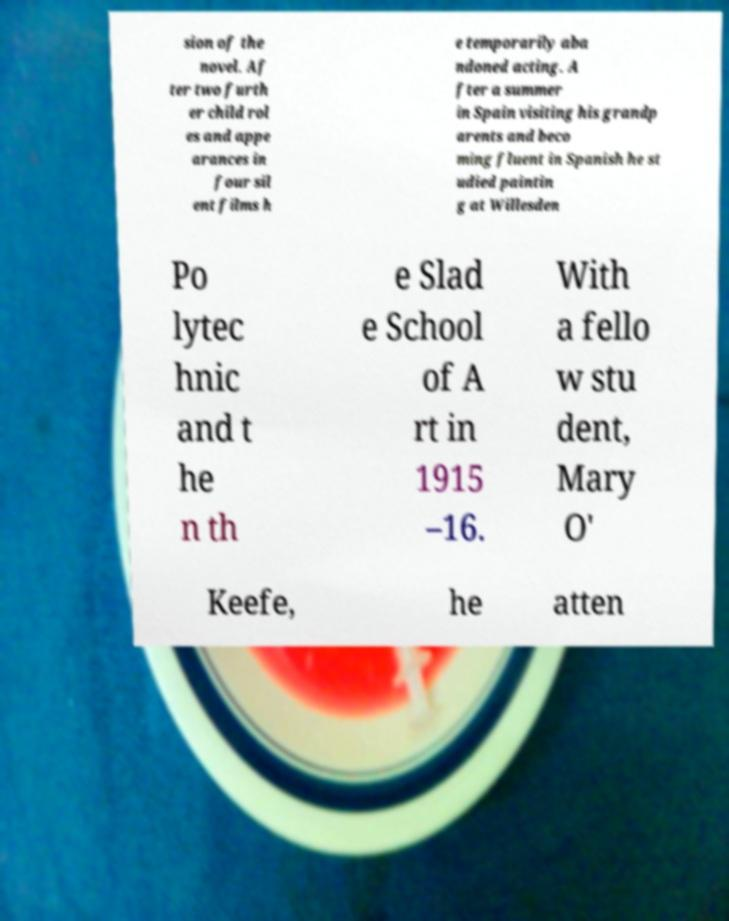Please identify and transcribe the text found in this image. sion of the novel. Af ter two furth er child rol es and appe arances in four sil ent films h e temporarily aba ndoned acting. A fter a summer in Spain visiting his grandp arents and beco ming fluent in Spanish he st udied paintin g at Willesden Po lytec hnic and t he n th e Slad e School of A rt in 1915 –16. With a fello w stu dent, Mary O' Keefe, he atten 